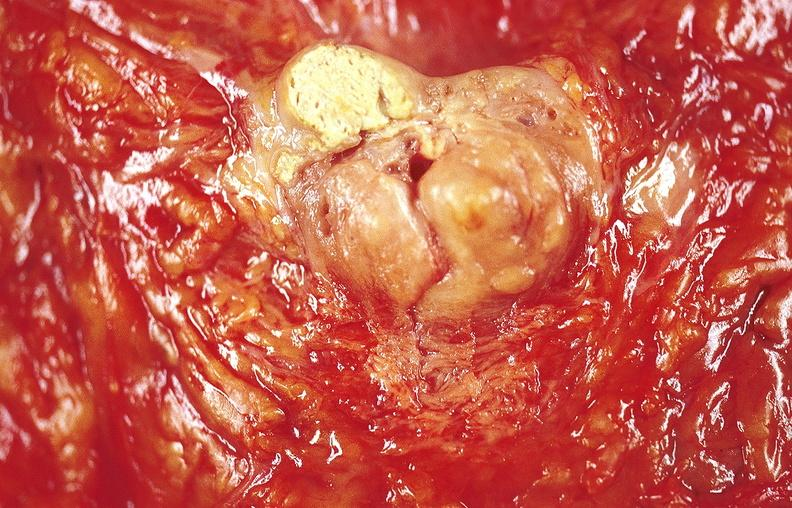does anencephaly show gastric ulcer?
Answer the question using a single word or phrase. No 